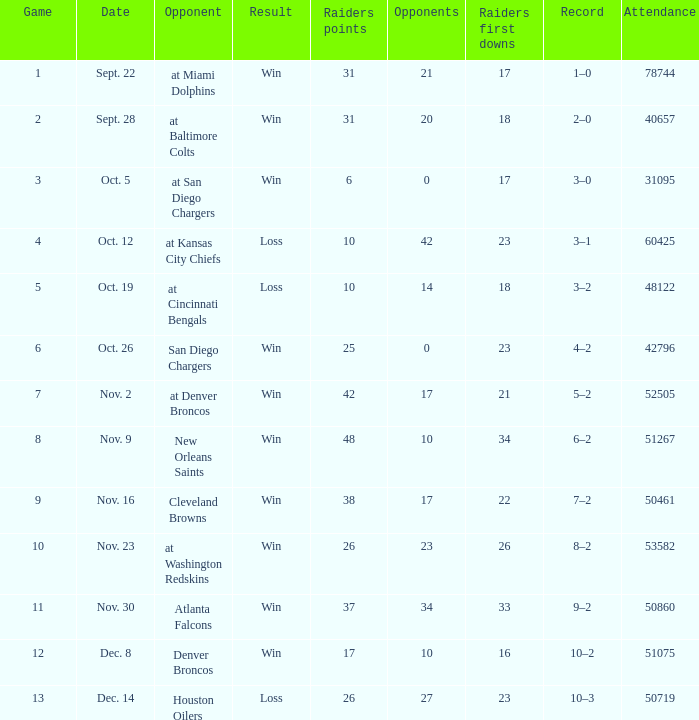Give me the full table as a dictionary. {'header': ['Game', 'Date', 'Opponent', 'Result', 'Raiders points', 'Opponents', 'Raiders first downs', 'Record', 'Attendance'], 'rows': [['1', 'Sept. 22', 'at Miami Dolphins', 'Win', '31', '21', '17', '1–0', '78744'], ['2', 'Sept. 28', 'at Baltimore Colts', 'Win', '31', '20', '18', '2–0', '40657'], ['3', 'Oct. 5', 'at San Diego Chargers', 'Win', '6', '0', '17', '3–0', '31095'], ['4', 'Oct. 12', 'at Kansas City Chiefs', 'Loss', '10', '42', '23', '3–1', '60425'], ['5', 'Oct. 19', 'at Cincinnati Bengals', 'Loss', '10', '14', '18', '3–2', '48122'], ['6', 'Oct. 26', 'San Diego Chargers', 'Win', '25', '0', '23', '4–2', '42796'], ['7', 'Nov. 2', 'at Denver Broncos', 'Win', '42', '17', '21', '5–2', '52505'], ['8', 'Nov. 9', 'New Orleans Saints', 'Win', '48', '10', '34', '6–2', '51267'], ['9', 'Nov. 16', 'Cleveland Browns', 'Win', '38', '17', '22', '7–2', '50461'], ['10', 'Nov. 23', 'at Washington Redskins', 'Win', '26', '23', '26', '8–2', '53582'], ['11', 'Nov. 30', 'Atlanta Falcons', 'Win', '37', '34', '33', '9–2', '50860'], ['12', 'Dec. 8', 'Denver Broncos', 'Win', '17', '10', '16', '10–2', '51075'], ['13', 'Dec. 14', 'Houston Oilers', 'Loss', '26', '27', '23', '10–3', '50719']]} What's the score in the match played against 42? 3–1. 